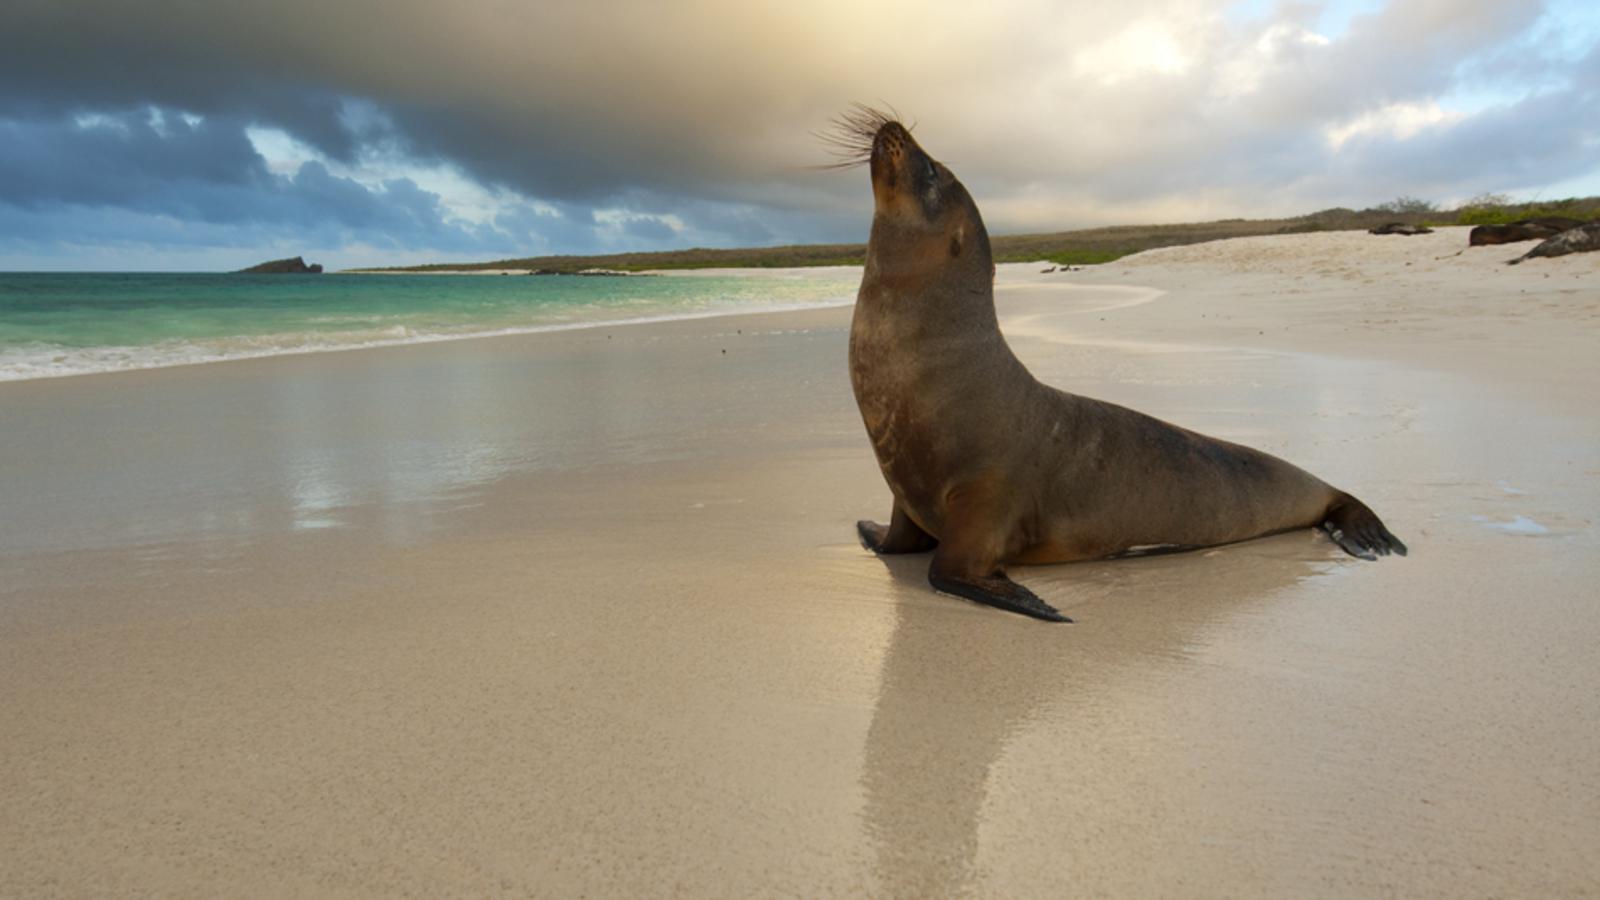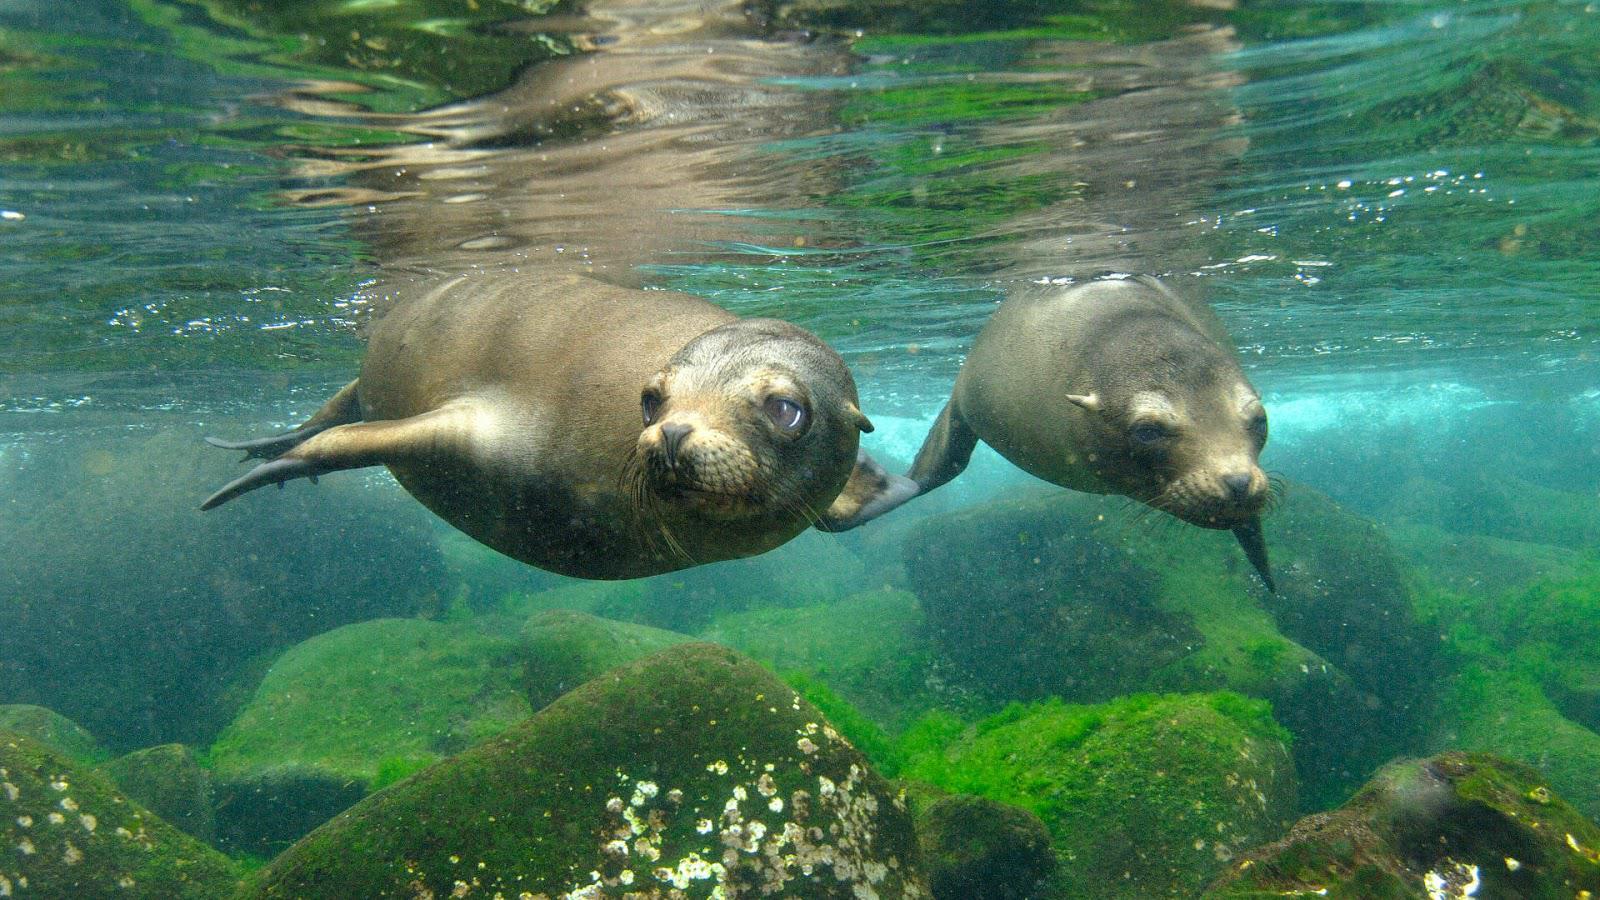The first image is the image on the left, the second image is the image on the right. Considering the images on both sides, is "There are at least two seals in the right image swimming underwater." valid? Answer yes or no. Yes. The first image is the image on the left, the second image is the image on the right. Examine the images to the left and right. Is the description "A total of two seals are shown, all of them swimming underwater, and one seal is swimming forward and eyeing the camera." accurate? Answer yes or no. No. 